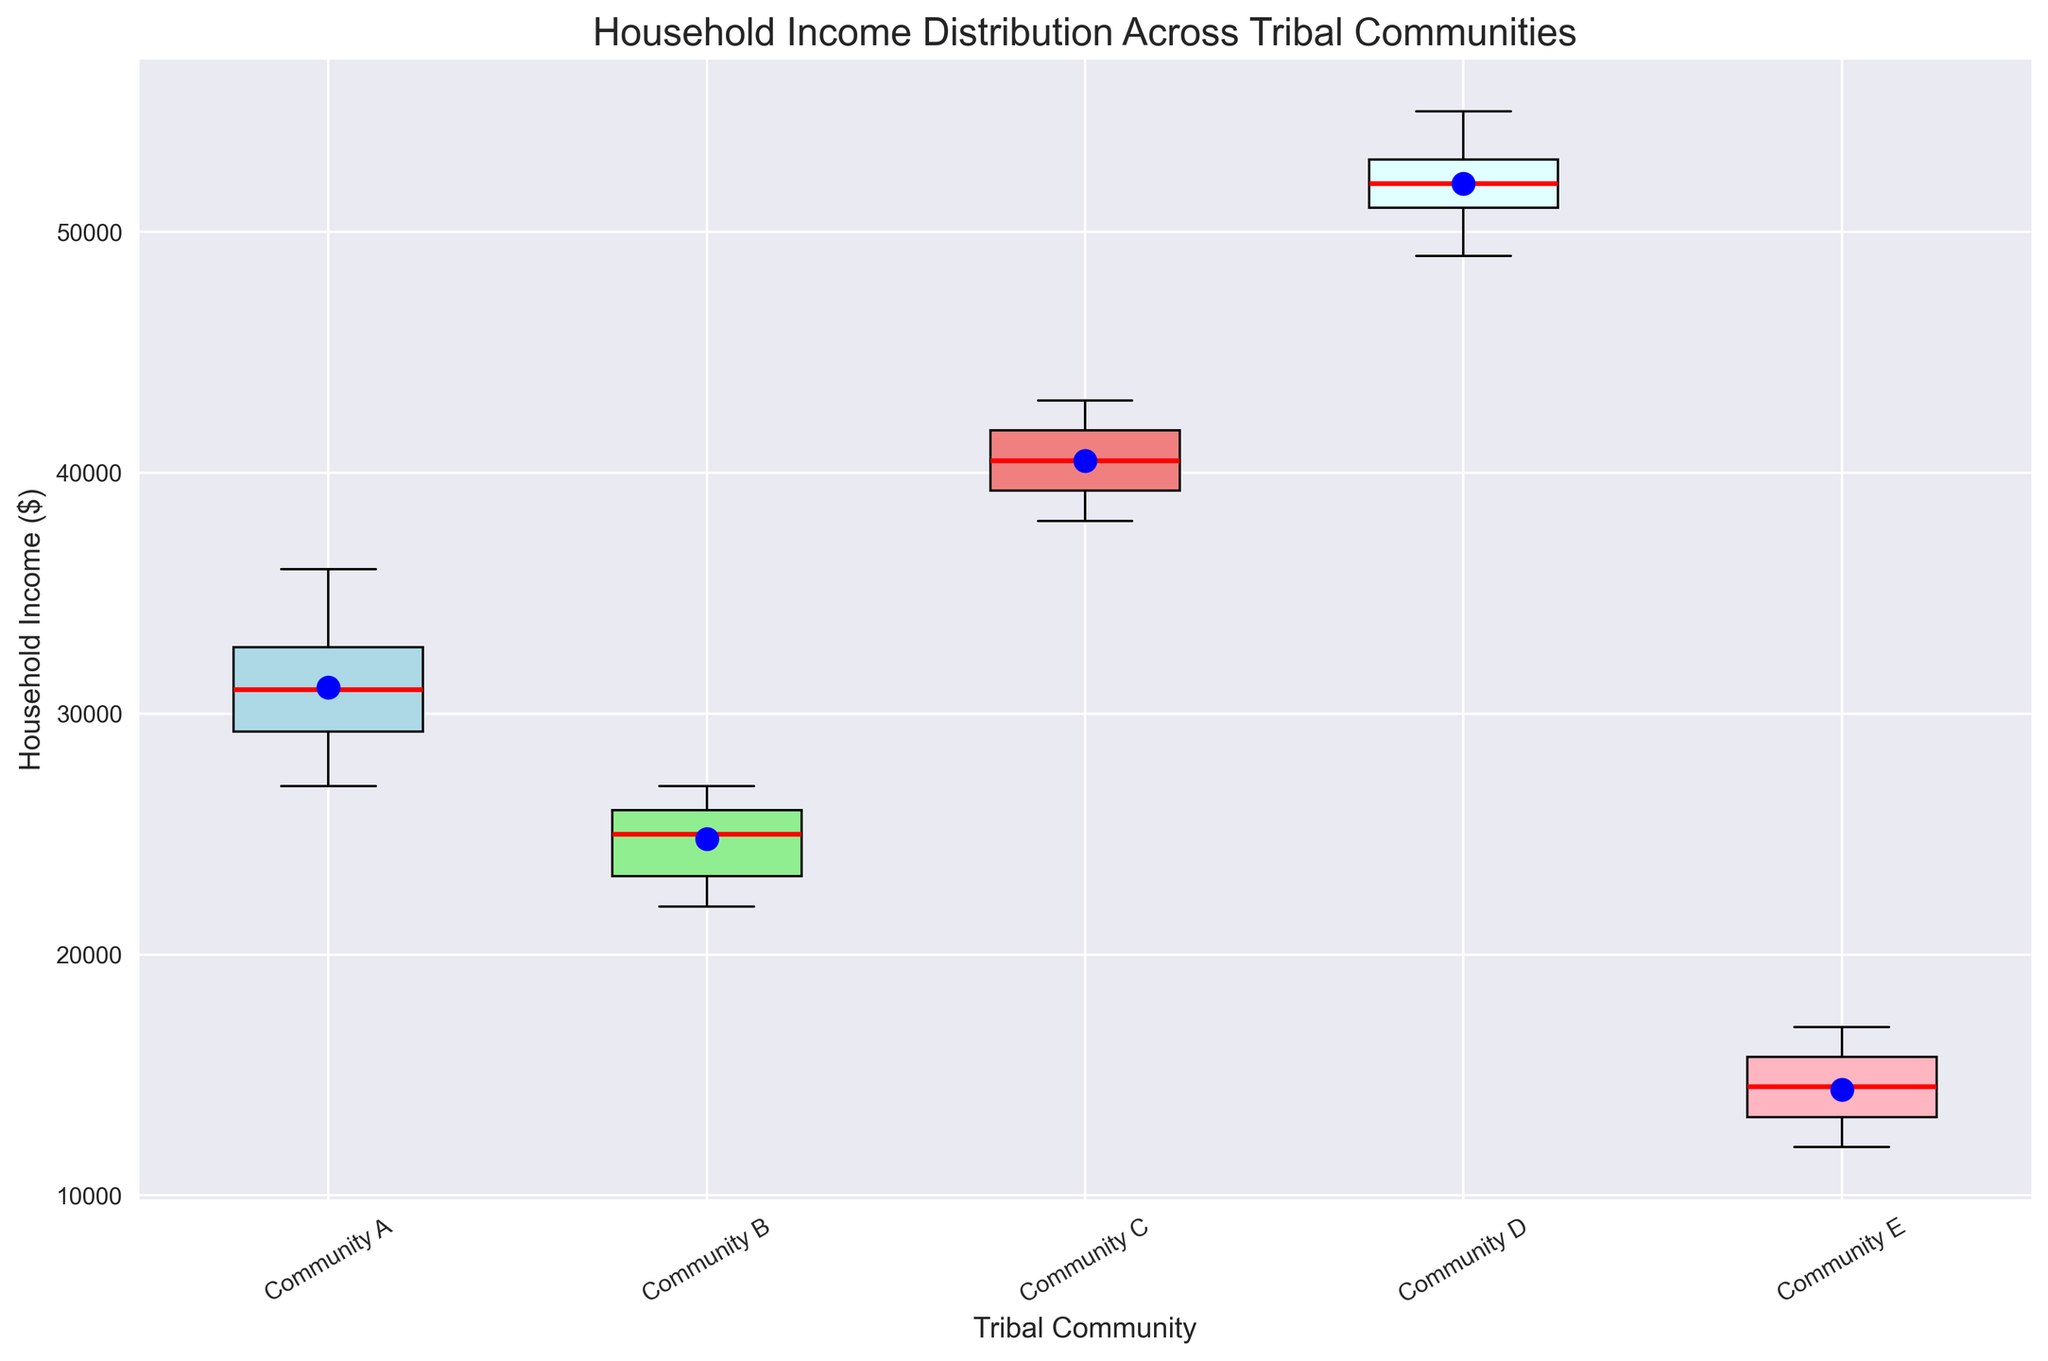What's the median household income for Community A? The box plot typically shows the median as a line within the box. For Community A, locate this line.
Answer: 31000 Which tribal community has the highest mean household income? The mean is usually indicated by a dot or a cross on the box plot. For Community D, look for the blue dot within the box, which is higher than those in other communities.
Answer: Community D Are the income distributions of Community C and Community D overlapping? Compare the lengths of the boxes (interquartile ranges) and the whiskers (spread of the data points). Community C’s upper whisker does not overlap with Community D's lower whisker.
Answer: No Which community has the widest spread of household income? The spread of income is shown by the length of the whiskers. Community E has the widest distribution as its whiskers are the most extended.
Answer: Community E What's the difference between the medians of Community C and Community E? Locate the medians for both communities on the plot. Community C's median is at 41000 and Community E's is at 14000. The difference is 41000 - 14000.
Answer: 27000 How does the interquartile range (IQR) of Community B compare to that of Community D? IQR is shown by the lengths of the boxes. Community B's IQR is smaller, represented by a shorter box than Community D.
Answer: Community B's IQR is smaller Which community has the most consistent household income distribution? Consistency can be inferred from the shortest box and whiskers. Community B appears to have the shortest box and whiskers, indicating less variation in income.
Answer: Community B Is the mean income higher or lower than the median income in Community A? Look for the positions of the median line and the mean dot. In Community A, the mean (blue dot) is slightly higher than the median line.
Answer: Higher 